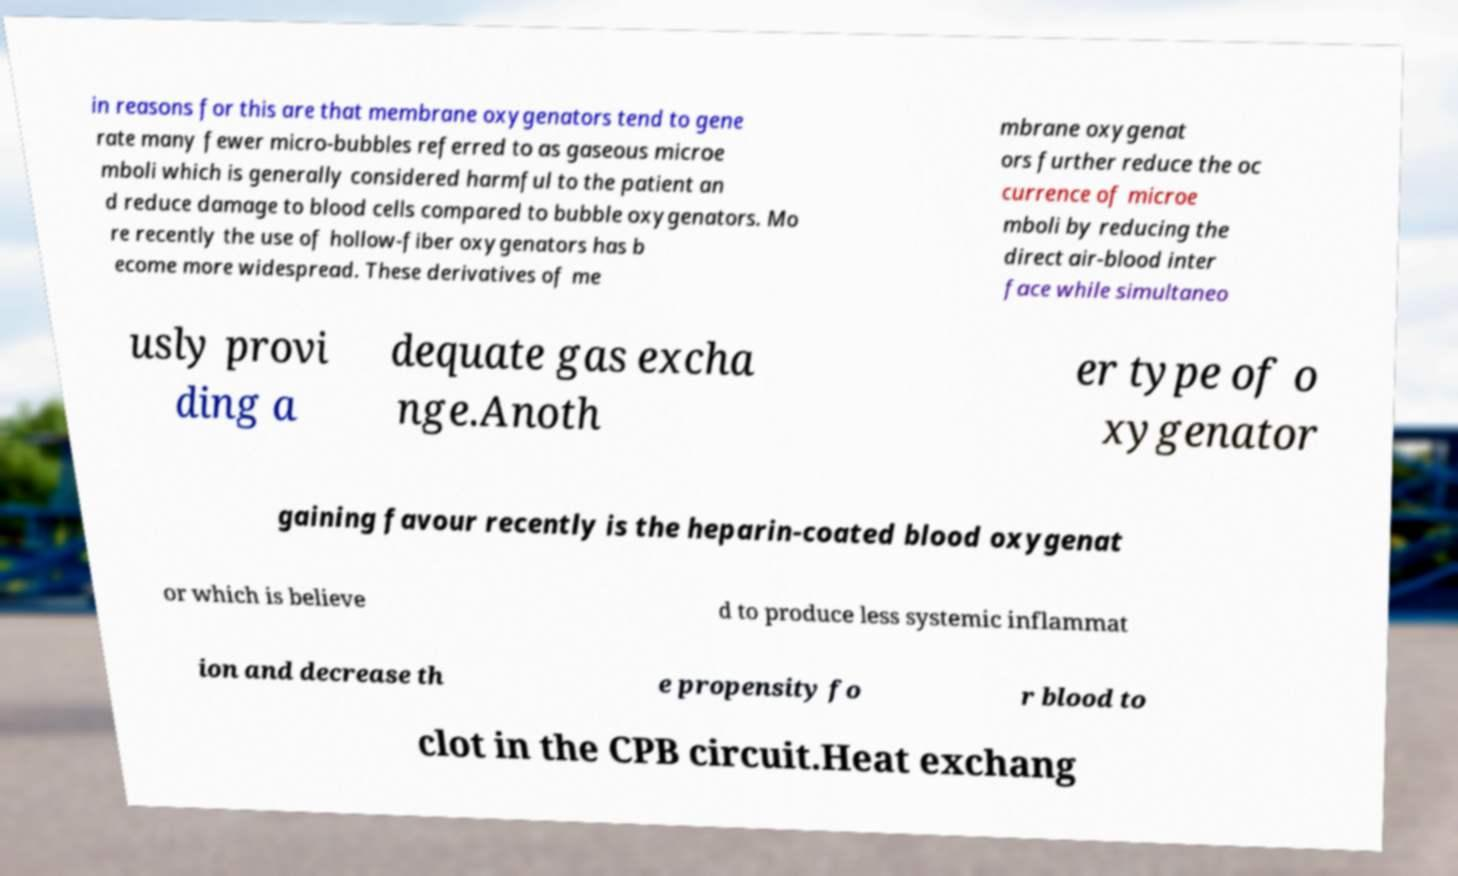Please read and relay the text visible in this image. What does it say? in reasons for this are that membrane oxygenators tend to gene rate many fewer micro-bubbles referred to as gaseous microe mboli which is generally considered harmful to the patient an d reduce damage to blood cells compared to bubble oxygenators. Mo re recently the use of hollow-fiber oxygenators has b ecome more widespread. These derivatives of me mbrane oxygenat ors further reduce the oc currence of microe mboli by reducing the direct air-blood inter face while simultaneo usly provi ding a dequate gas excha nge.Anoth er type of o xygenator gaining favour recently is the heparin-coated blood oxygenat or which is believe d to produce less systemic inflammat ion and decrease th e propensity fo r blood to clot in the CPB circuit.Heat exchang 